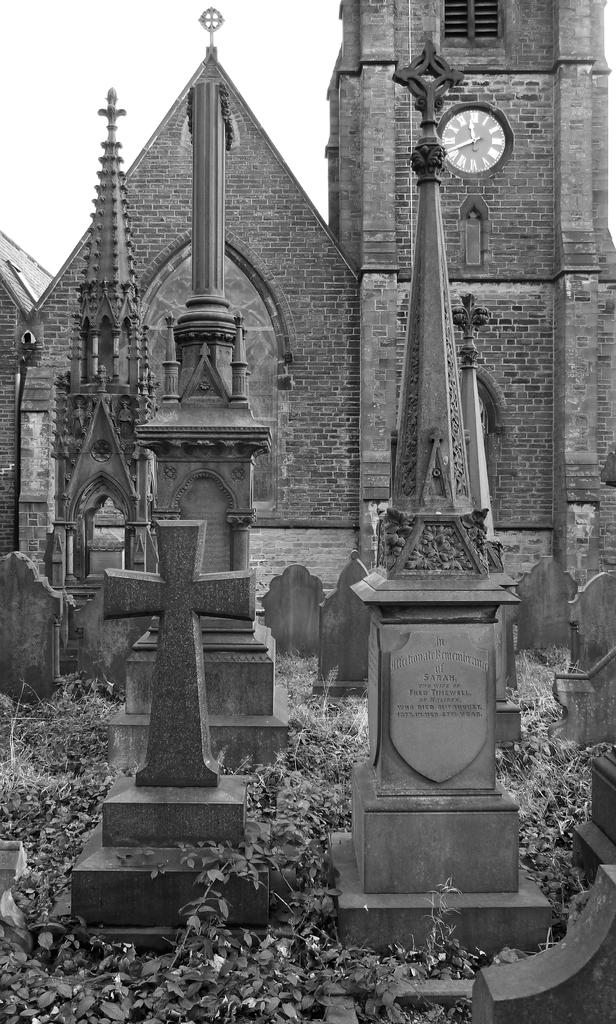What is the color scheme of the image? The image is black and white. What type of structures are present in the image? There are memorial walls in the image. What can be seen in the background of the image? There is a brick wall in the background of the image. What is attached to the brick wall? There is a clock on the brick wall. Is there any opening in the walls or structures in the image? Yes, there is a window in the image. What type of jam is being spread on the territory in the image? There is no jam or territory present in the image; it features memorial walls, a brick wall, a clock, and a window. How many sticks are visible in the image? There are no sticks visible in the image. 